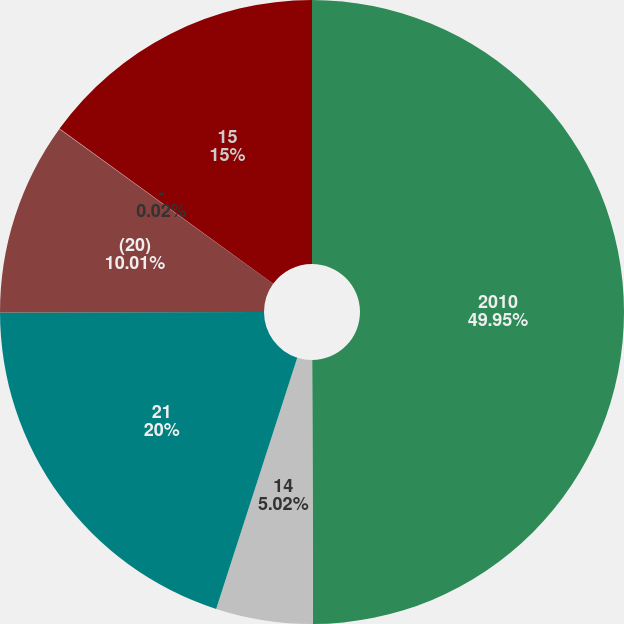<chart> <loc_0><loc_0><loc_500><loc_500><pie_chart><fcel>2010<fcel>14<fcel>21<fcel>(20)<fcel>-<fcel>15<nl><fcel>49.95%<fcel>5.02%<fcel>20.0%<fcel>10.01%<fcel>0.02%<fcel>15.0%<nl></chart> 